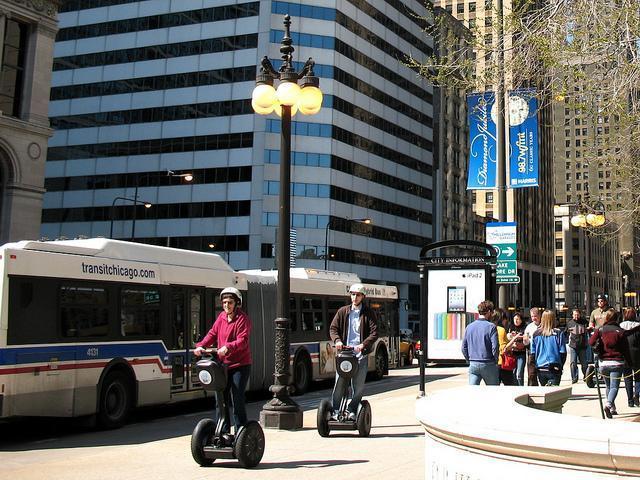How many people can be seen?
Give a very brief answer. 4. How many giraffes are there?
Give a very brief answer. 0. 